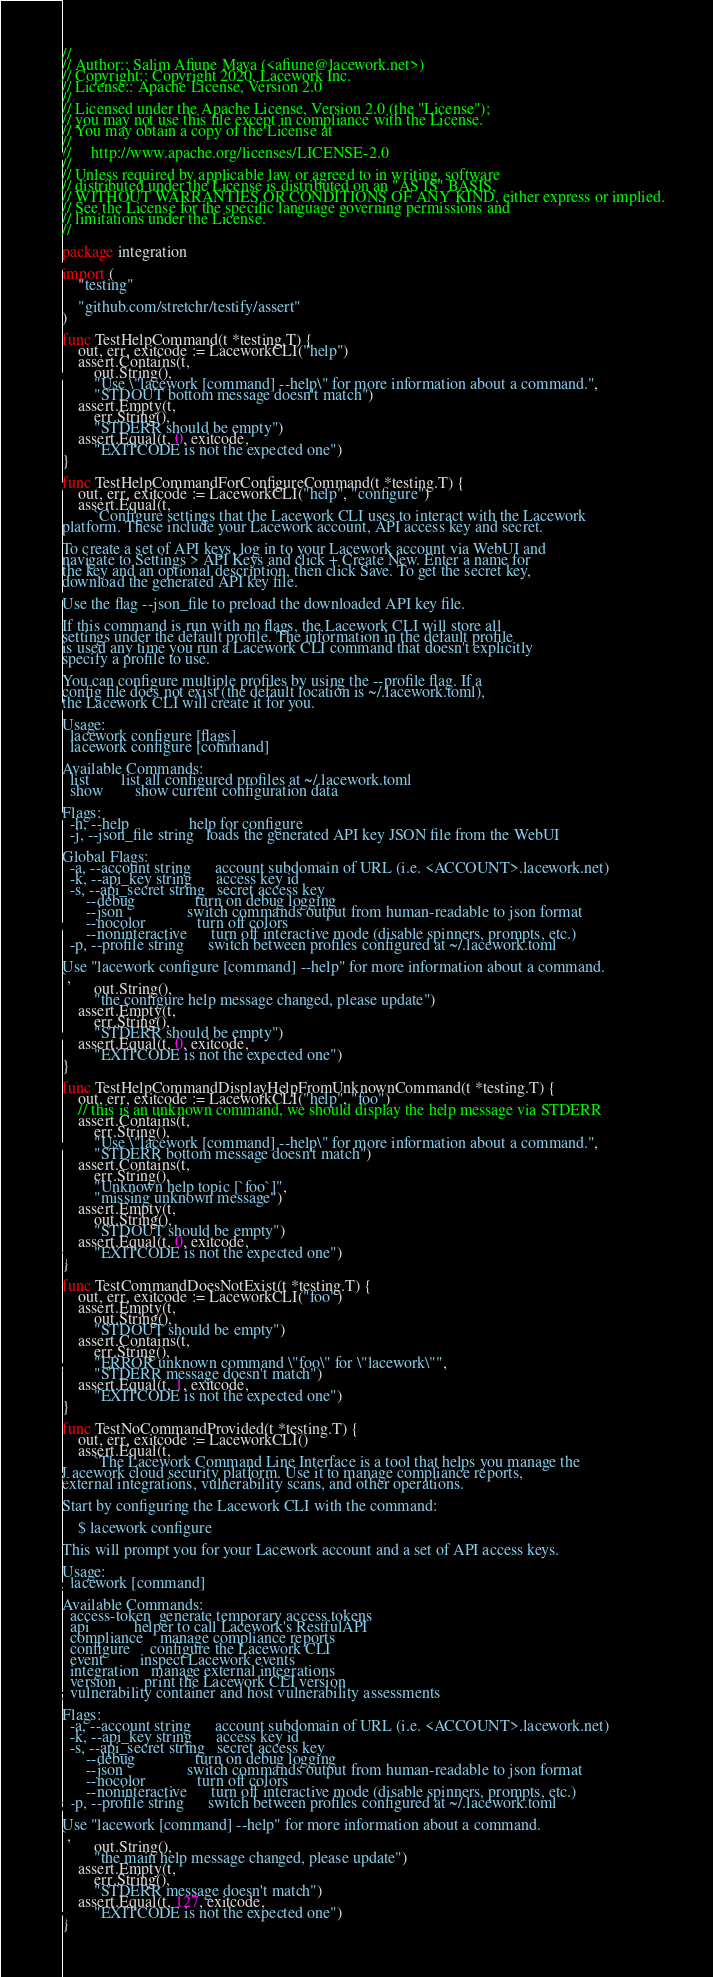<code> <loc_0><loc_0><loc_500><loc_500><_Go_>//
// Author:: Salim Afiune Maya (<afiune@lacework.net>)
// Copyright:: Copyright 2020, Lacework Inc.
// License:: Apache License, Version 2.0
//
// Licensed under the Apache License, Version 2.0 (the "License");
// you may not use this file except in compliance with the License.
// You may obtain a copy of the License at
//
//     http://www.apache.org/licenses/LICENSE-2.0
//
// Unless required by applicable law or agreed to in writing, software
// distributed under the License is distributed on an "AS IS" BASIS,
// WITHOUT WARRANTIES OR CONDITIONS OF ANY KIND, either express or implied.
// See the License for the specific language governing permissions and
// limitations under the License.
//

package integration

import (
	"testing"

	"github.com/stretchr/testify/assert"
)

func TestHelpCommand(t *testing.T) {
	out, err, exitcode := LaceworkCLI("help")
	assert.Contains(t,
		out.String(),
		"Use \"lacework [command] --help\" for more information about a command.",
		"STDOUT bottom message doesn't match")
	assert.Empty(t,
		err.String(),
		"STDERR should be empty")
	assert.Equal(t, 0, exitcode,
		"EXITCODE is not the expected one")
}

func TestHelpCommandForConfigureCommand(t *testing.T) {
	out, err, exitcode := LaceworkCLI("help", "configure")
	assert.Equal(t,
		`Configure settings that the Lacework CLI uses to interact with the Lacework
platform. These include your Lacework account, API access key and secret.

To create a set of API keys, log in to your Lacework account via WebUI and
navigate to Settings > API Keys and click + Create New. Enter a name for
the key and an optional description, then click Save. To get the secret key,
download the generated API key file.

Use the flag --json_file to preload the downloaded API key file.

If this command is run with no flags, the Lacework CLI will store all
settings under the default profile. The information in the default profile
is used any time you run a Lacework CLI command that doesn't explicitly
specify a profile to use.

You can configure multiple profiles by using the --profile flag. If a
config file does not exist (the default location is ~/.lacework.toml),
the Lacework CLI will create it for you.

Usage:
  lacework configure [flags]
  lacework configure [command]

Available Commands:
  list        list all configured profiles at ~/.lacework.toml
  show        show current configuration data

Flags:
  -h, --help               help for configure
  -j, --json_file string   loads the generated API key JSON file from the WebUI

Global Flags:
  -a, --account string      account subdomain of URL (i.e. <ACCOUNT>.lacework.net)
  -k, --api_key string      access key id
  -s, --api_secret string   secret access key
      --debug               turn on debug logging
      --json                switch commands output from human-readable to json format
      --nocolor             turn off colors
      --noninteractive      turn off interactive mode (disable spinners, prompts, etc.)
  -p, --profile string      switch between profiles configured at ~/.lacework.toml

Use "lacework configure [command] --help" for more information about a command.
`,
		out.String(),
		"the configure help message changed, please update")
	assert.Empty(t,
		err.String(),
		"STDERR should be empty")
	assert.Equal(t, 0, exitcode,
		"EXITCODE is not the expected one")
}

func TestHelpCommandDisplayHelpFromUnknownCommand(t *testing.T) {
	out, err, exitcode := LaceworkCLI("help", "foo")
	// this is an unknown command, we should display the help message via STDERR
	assert.Contains(t,
		err.String(),
		"Use \"lacework [command] --help\" for more information about a command.",
		"STDERR bottom message doesn't match")
	assert.Contains(t,
		err.String(),
		"Unknown help topic [`foo`]",
		"missing unknown message")
	assert.Empty(t,
		out.String(),
		"STDOUT should be empty")
	assert.Equal(t, 0, exitcode,
		"EXITCODE is not the expected one")
}

func TestCommandDoesNotExist(t *testing.T) {
	out, err, exitcode := LaceworkCLI("foo")
	assert.Empty(t,
		out.String(),
		"STDOUT should be empty")
	assert.Contains(t,
		err.String(),
		"ERROR unknown command \"foo\" for \"lacework\"",
		"STDERR message doesn't match")
	assert.Equal(t, 1, exitcode,
		"EXITCODE is not the expected one")
}

func TestNoCommandProvided(t *testing.T) {
	out, err, exitcode := LaceworkCLI()
	assert.Equal(t,
		`The Lacework Command Line Interface is a tool that helps you manage the
Lacework cloud security platform. Use it to manage compliance reports,
external integrations, vulnerability scans, and other operations.

Start by configuring the Lacework CLI with the command:

    $ lacework configure

This will prompt you for your Lacework account and a set of API access keys.

Usage:
  lacework [command]

Available Commands:
  access-token  generate temporary access tokens
  api           helper to call Lacework's RestfulAPI
  compliance    manage compliance reports
  configure     configure the Lacework CLI
  event         inspect Lacework events
  integration   manage external integrations
  version       print the Lacework CLI version
  vulnerability container and host vulnerability assessments

Flags:
  -a, --account string      account subdomain of URL (i.e. <ACCOUNT>.lacework.net)
  -k, --api_key string      access key id
  -s, --api_secret string   secret access key
      --debug               turn on debug logging
      --json                switch commands output from human-readable to json format
      --nocolor             turn off colors
      --noninteractive      turn off interactive mode (disable spinners, prompts, etc.)
  -p, --profile string      switch between profiles configured at ~/.lacework.toml

Use "lacework [command] --help" for more information about a command.
`,
		out.String(),
		"the main help message changed, please update")
	assert.Empty(t,
		err.String(),
		"STDERR message doesn't match")
	assert.Equal(t, 127, exitcode,
		"EXITCODE is not the expected one")
}
</code> 